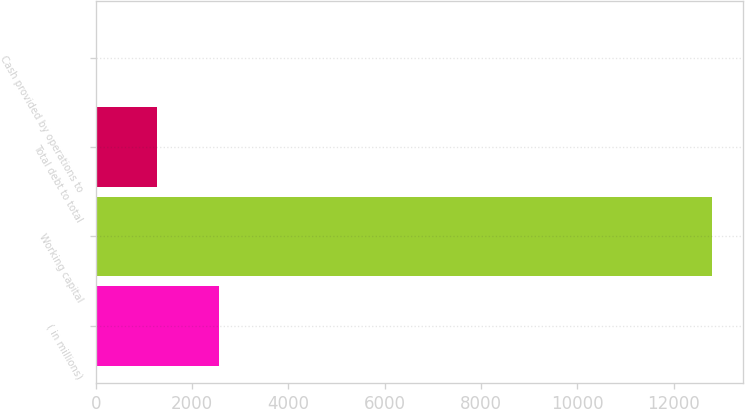Convert chart. <chart><loc_0><loc_0><loc_500><loc_500><bar_chart><fcel>( in millions)<fcel>Working capital<fcel>Total debt to total<fcel>Cash provided by operations to<nl><fcel>2558.37<fcel>12791<fcel>1279.29<fcel>0.21<nl></chart> 